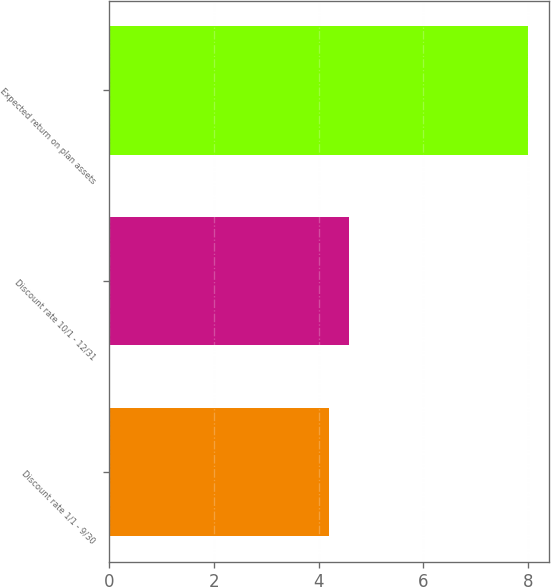Convert chart to OTSL. <chart><loc_0><loc_0><loc_500><loc_500><bar_chart><fcel>Discount rate 1/1 - 9/30<fcel>Discount rate 10/1 - 12/31<fcel>Expected return on plan assets<nl><fcel>4.2<fcel>4.58<fcel>8<nl></chart> 